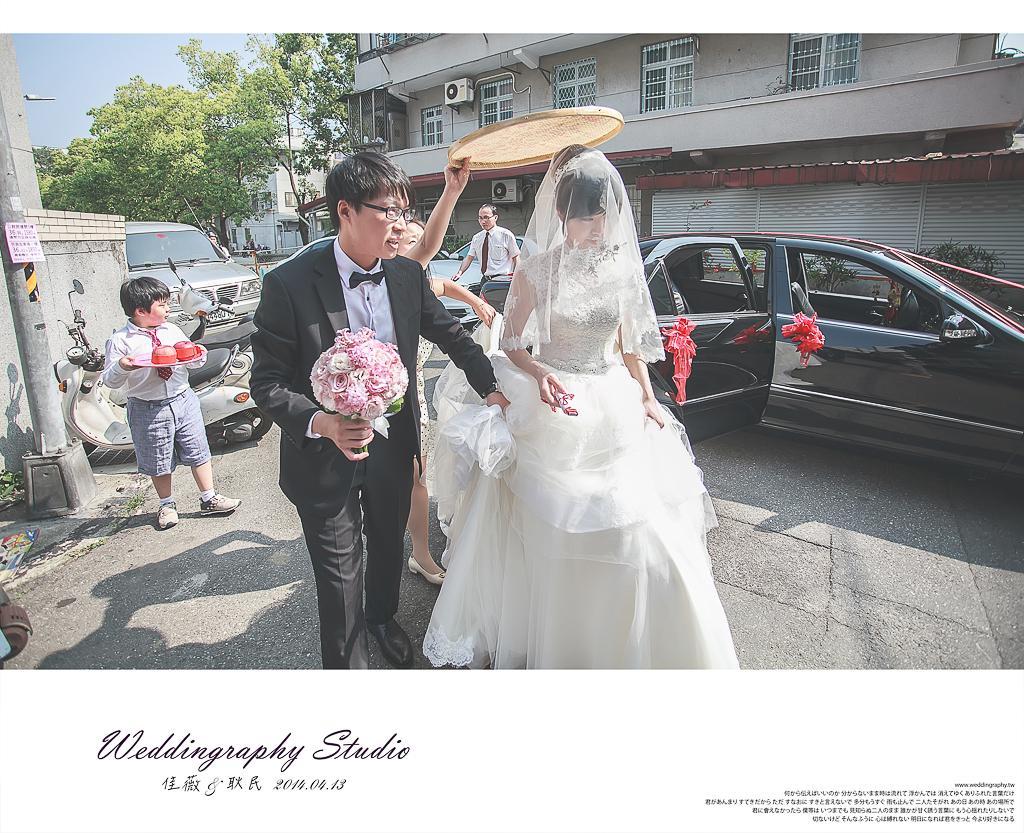Can you describe this image briefly? In this image in the center there is one man and one woman walking, and man is holding a flower bouquet. And in the background there are some people and cars, pole, trees, boards, vehicles, and at the bottom there is a road and at the bottom of the image there is text. And in the background there is building and trees. 